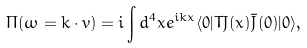Convert formula to latex. <formula><loc_0><loc_0><loc_500><loc_500>\Pi ( \omega = k \cdot v ) = i \int d ^ { 4 } x e ^ { i k x } \langle 0 | T J ( x ) \bar { J } ( 0 ) | 0 \rangle ,</formula> 